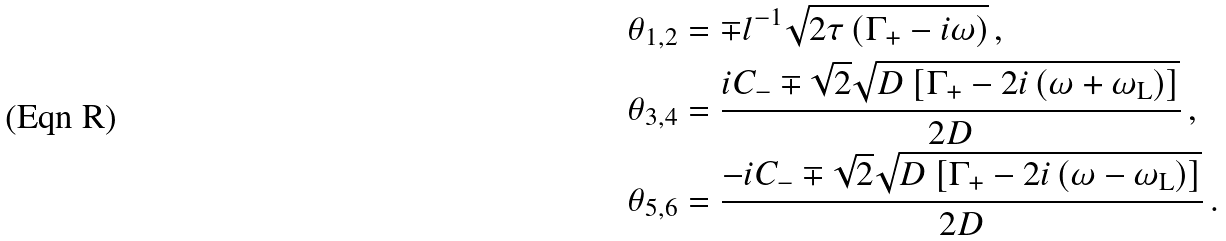Convert formula to latex. <formula><loc_0><loc_0><loc_500><loc_500>\theta _ { 1 , 2 } & = \mp l ^ { - 1 } \sqrt { 2 \tau \left ( \Gamma _ { + } - i \omega \right ) } \, , \\ \theta _ { 3 , 4 } & = \frac { i C _ { - } \mp \sqrt { 2 } \sqrt { D \left [ \Gamma _ { + } - 2 i \left ( \omega + \omega _ { \text {L} } \right ) \right ] } } { 2 D } \, , \\ \theta _ { 5 , 6 } & = \frac { - i C _ { - } \mp \sqrt { 2 } \sqrt { D \left [ \Gamma _ { + } - 2 i \left ( \omega - \omega _ { \text {L} } \right ) \right ] } } { 2 D } \, .</formula> 